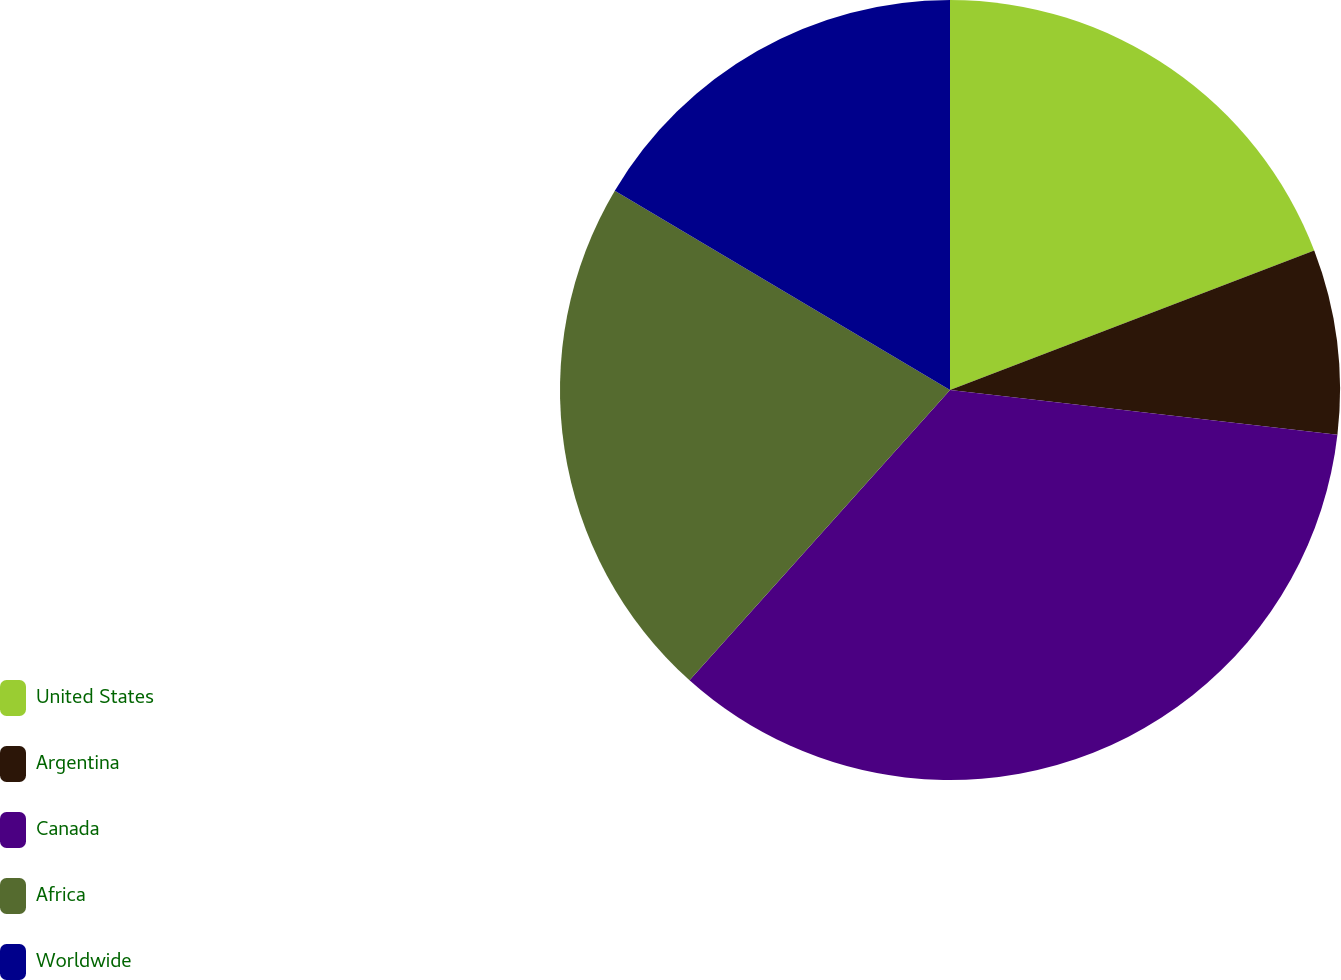Convert chart. <chart><loc_0><loc_0><loc_500><loc_500><pie_chart><fcel>United States<fcel>Argentina<fcel>Canada<fcel>Africa<fcel>Worldwide<nl><fcel>19.18%<fcel>7.65%<fcel>34.81%<fcel>21.9%<fcel>16.46%<nl></chart> 